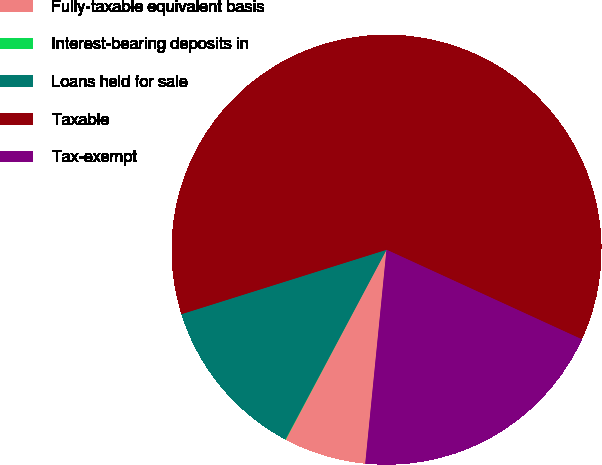Convert chart to OTSL. <chart><loc_0><loc_0><loc_500><loc_500><pie_chart><fcel>Fully-taxable equivalent basis<fcel>Interest-bearing deposits in<fcel>Loans held for sale<fcel>Taxable<fcel>Tax-exempt<nl><fcel>6.19%<fcel>0.03%<fcel>12.36%<fcel>61.69%<fcel>19.73%<nl></chart> 